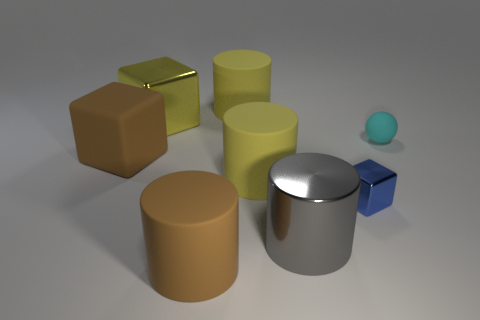Subtract all gray metal cylinders. How many cylinders are left? 3 Subtract all purple balls. How many yellow cylinders are left? 2 Subtract all gray cylinders. How many cylinders are left? 3 Add 1 blocks. How many objects exist? 9 Subtract all balls. How many objects are left? 7 Subtract all purple cylinders. Subtract all cyan spheres. How many cylinders are left? 4 Subtract all small cyan spheres. Subtract all purple metal blocks. How many objects are left? 7 Add 2 big yellow objects. How many big yellow objects are left? 5 Add 6 metal objects. How many metal objects exist? 9 Subtract 0 cyan cubes. How many objects are left? 8 